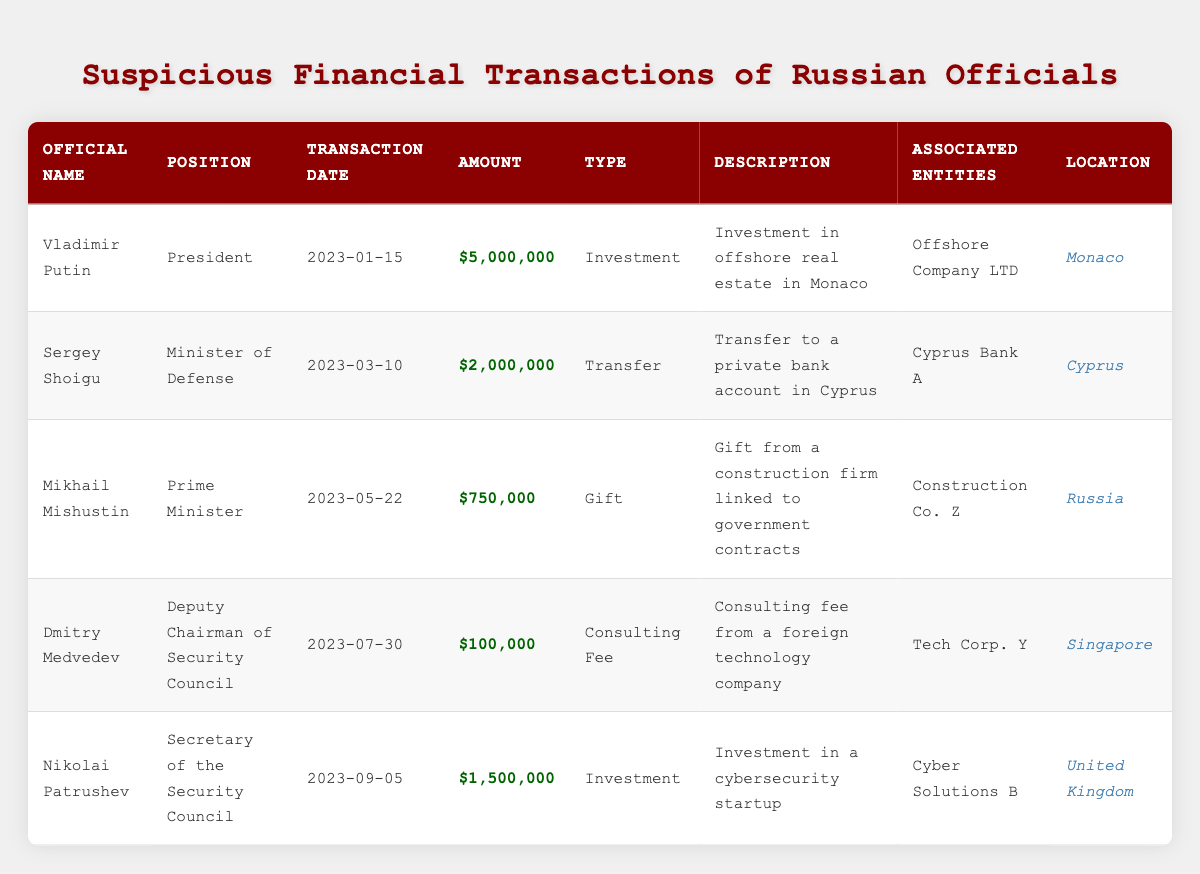What is the total amount of transactions attributed to Vladimir Putin? The table shows that Vladimir Putin has one transaction listed with an amount of $5,000,000. Since there is only one transaction, the total amount is simply $5,000,000.
Answer: $5,000,000 What types of financial transactions are listed for Sergey Shoigu? Sergey Shoigu has one transaction listed, which is a transfer for $2,000,000. Therefore, the type of financial transaction for him is 'Transfer.'
Answer: Transfer Is there any transaction involving Mikhail Mishustin that is categorized as an investment? The only transaction listed for Mikhail Mishustin is a gift from a construction firm for $750,000. Since there are no investments mentioned, the answer is no.
Answer: No What are the associated entities for the transaction made by Dmitry Medvedev? The table indicates that Dmitry Medvedev has one transaction listed, which is a consulting fee from a foreign technology company, and the associated entity is 'Tech Corp. Y.'
Answer: Tech Corp. Y How much more money was transferred by Sergey Shoigu compared to Dmitry Medvedev? Sergey Shoigu had a transfer of $2,000,000, while Dmitry Medvedev received a consulting fee of $100,000. To find the difference, subtract $100,000 from $2,000,000, which equals $1,900,000.
Answer: $1,900,000 What is the average transaction amount of the five officials listed? The total amounts of the transactions are $5,000,000 (Putin) + $2,000,000 (Shoigu) + $750,000 (Mishustin) + $100,000 (Medvedev) + $1,500,000 (Patrushev) = $9,350,000. There are 5 officials, so the average is $9,350,000 / 5 = $1,870,000.
Answer: $1,870,000 Did any transactions occur in the United Kingdom? Looking at the table, there is one transaction made by Nikolai Patrushev in the United Kingdom. Therefore, the answer is yes.
Answer: Yes What was the highest transaction amount and who was responsible for it? The highest transaction amount listed is $5,000,000 made by Vladimir Putin on January 15, 2023.
Answer: $5,000,000 by Vladimir Putin What was the purpose of the investment transaction made by Nikolai Patrushev? The transaction listed for Nikolai Patrushev is an investment in a cybersecurity startup, as stated in the description.
Answer: Investment in a cybersecurity startup 